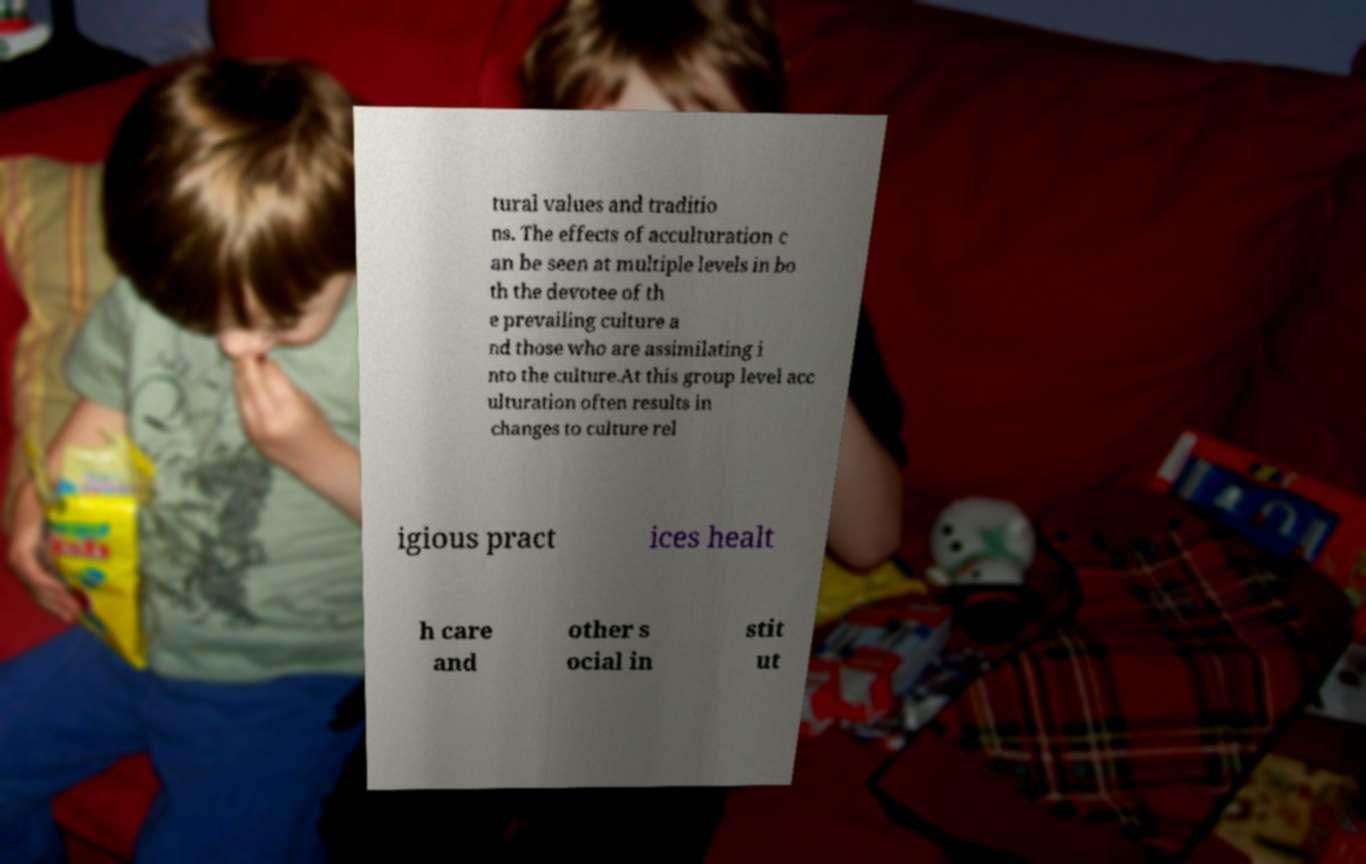Could you extract and type out the text from this image? tural values and traditio ns. The effects of acculturation c an be seen at multiple levels in bo th the devotee of th e prevailing culture a nd those who are assimilating i nto the culture.At this group level acc ulturation often results in changes to culture rel igious pract ices healt h care and other s ocial in stit ut 